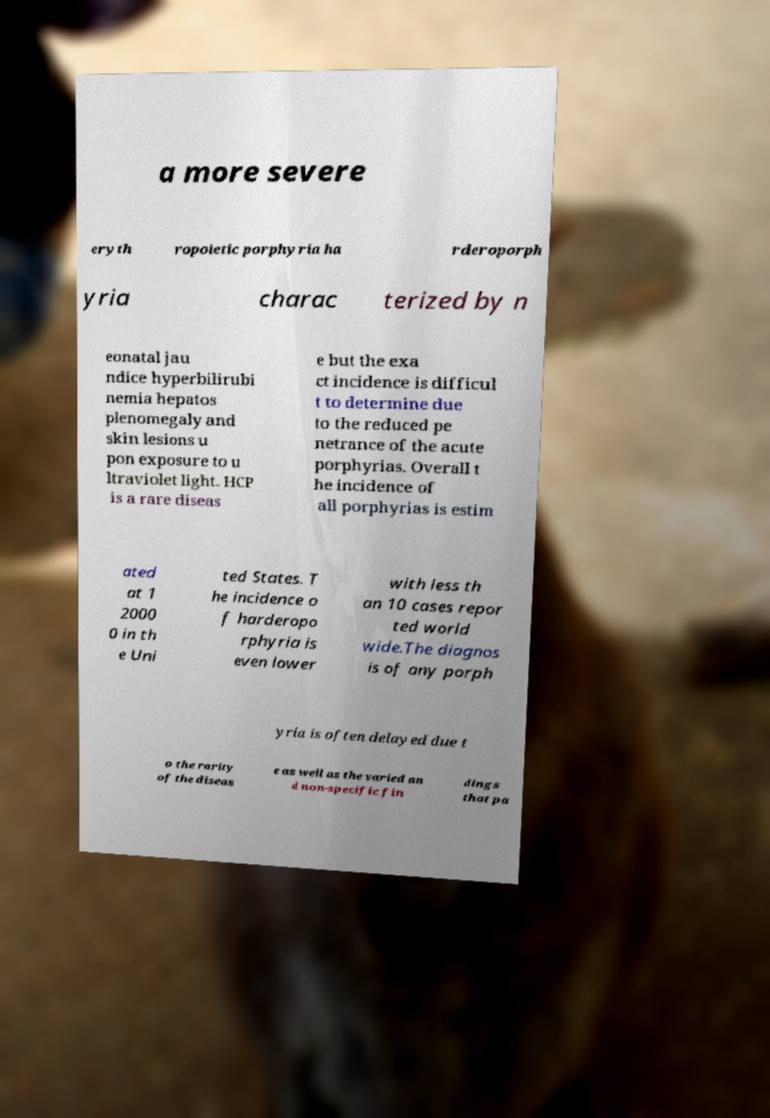I need the written content from this picture converted into text. Can you do that? a more severe eryth ropoietic porphyria ha rderoporph yria charac terized by n eonatal jau ndice hyperbilirubi nemia hepatos plenomegaly and skin lesions u pon exposure to u ltraviolet light. HCP is a rare diseas e but the exa ct incidence is difficul t to determine due to the reduced pe netrance of the acute porphyrias. Overall t he incidence of all porphyrias is estim ated at 1 2000 0 in th e Uni ted States. T he incidence o f harderopo rphyria is even lower with less th an 10 cases repor ted world wide.The diagnos is of any porph yria is often delayed due t o the rarity of the diseas e as well as the varied an d non-specific fin dings that pa 